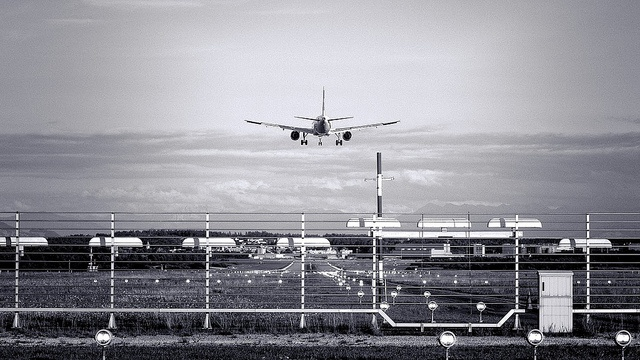Describe the objects in this image and their specific colors. I can see a airplane in gray, darkgray, lightgray, and black tones in this image. 